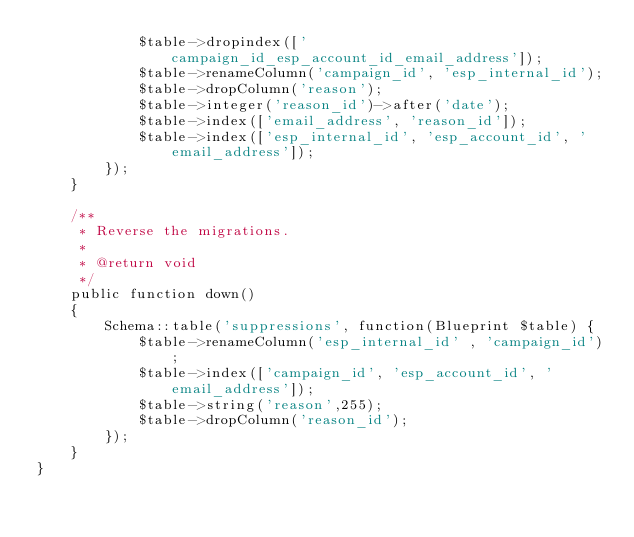Convert code to text. <code><loc_0><loc_0><loc_500><loc_500><_PHP_>            $table->dropindex(['campaign_id_esp_account_id_email_address']);
            $table->renameColumn('campaign_id', 'esp_internal_id');
            $table->dropColumn('reason');
            $table->integer('reason_id')->after('date');
            $table->index(['email_address', 'reason_id']);
            $table->index(['esp_internal_id', 'esp_account_id', 'email_address']);
        });
    }

    /**
     * Reverse the migrations.
     *
     * @return void
     */
    public function down()
    {
        Schema::table('suppressions', function(Blueprint $table) {
            $table->renameColumn('esp_internal_id' , 'campaign_id');
            $table->index(['campaign_id', 'esp_account_id', 'email_address']);
            $table->string('reason',255);
            $table->dropColumn('reason_id');
        });
    }
}
</code> 